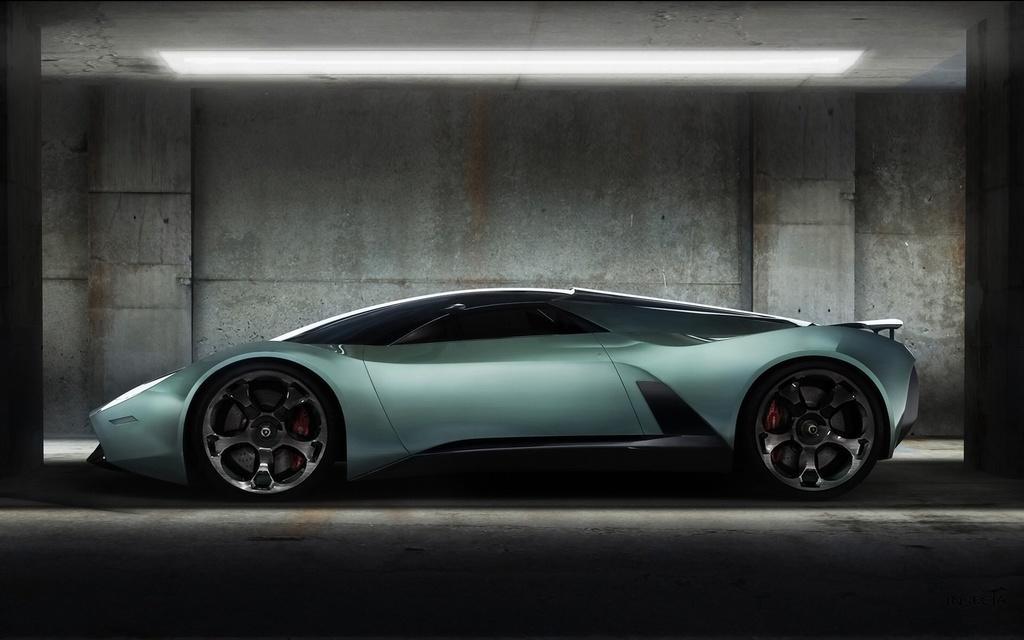Can you describe this image briefly? This picture contains a car which is parked in the parking lot. Beside that, we see a wall and pillars. At the top of the picture, we see the ceiling of the building. 